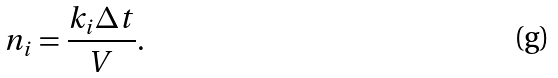Convert formula to latex. <formula><loc_0><loc_0><loc_500><loc_500>n _ { i } = \frac { k _ { i } \Delta t } { V } .</formula> 